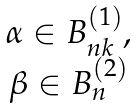<formula> <loc_0><loc_0><loc_500><loc_500>\begin{matrix} \alpha \in B _ { n k } ^ { ( 1 ) } , \\ \beta \in B _ { n } ^ { ( 2 ) } \end{matrix}</formula> 